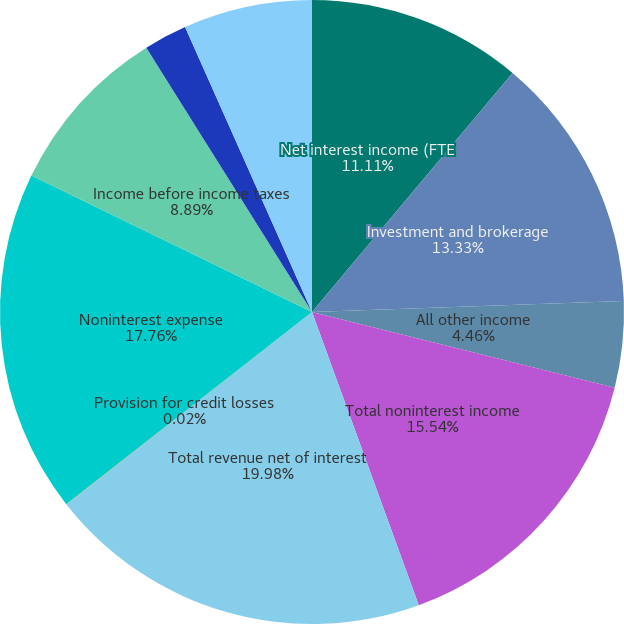<chart> <loc_0><loc_0><loc_500><loc_500><pie_chart><fcel>Net interest income (FTE<fcel>Investment and brokerage<fcel>All other income<fcel>Total noninterest income<fcel>Total revenue net of interest<fcel>Provision for credit losses<fcel>Noninterest expense<fcel>Income before income taxes<fcel>Income tax expense (FTE basis)<fcel>Net income<nl><fcel>11.11%<fcel>13.33%<fcel>4.46%<fcel>15.54%<fcel>19.98%<fcel>0.02%<fcel>17.76%<fcel>8.89%<fcel>2.24%<fcel>6.67%<nl></chart> 